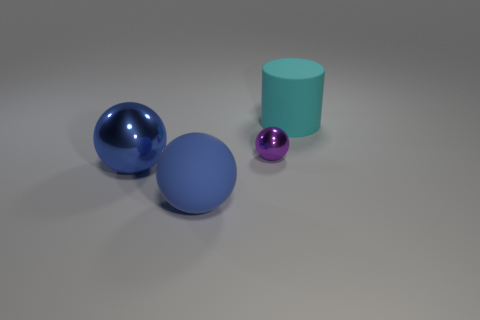How many blue spheres must be subtracted to get 1 blue spheres? 1 Subtract all yellow cylinders. How many blue spheres are left? 2 Subtract all metallic spheres. How many spheres are left? 1 Add 4 large yellow shiny blocks. How many objects exist? 8 Subtract all spheres. How many objects are left? 1 Subtract all gray spheres. Subtract all cyan blocks. How many spheres are left? 3 Add 1 big metal things. How many big metal things are left? 2 Add 4 green metal objects. How many green metal objects exist? 4 Subtract 0 blue cylinders. How many objects are left? 4 Subtract all gray spheres. Subtract all blue metal things. How many objects are left? 3 